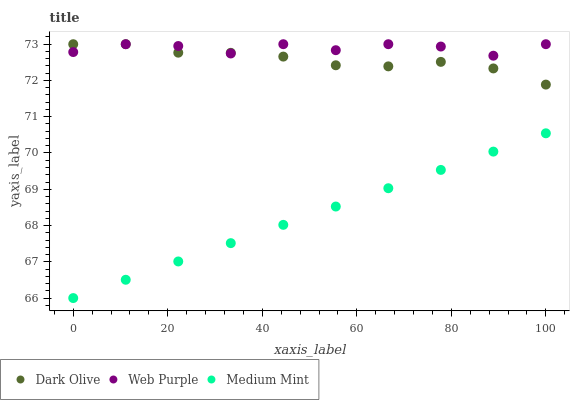Does Medium Mint have the minimum area under the curve?
Answer yes or no. Yes. Does Web Purple have the maximum area under the curve?
Answer yes or no. Yes. Does Dark Olive have the minimum area under the curve?
Answer yes or no. No. Does Dark Olive have the maximum area under the curve?
Answer yes or no. No. Is Medium Mint the smoothest?
Answer yes or no. Yes. Is Web Purple the roughest?
Answer yes or no. Yes. Is Dark Olive the smoothest?
Answer yes or no. No. Is Dark Olive the roughest?
Answer yes or no. No. Does Medium Mint have the lowest value?
Answer yes or no. Yes. Does Dark Olive have the lowest value?
Answer yes or no. No. Does Dark Olive have the highest value?
Answer yes or no. Yes. Is Medium Mint less than Dark Olive?
Answer yes or no. Yes. Is Web Purple greater than Medium Mint?
Answer yes or no. Yes. Does Web Purple intersect Dark Olive?
Answer yes or no. Yes. Is Web Purple less than Dark Olive?
Answer yes or no. No. Is Web Purple greater than Dark Olive?
Answer yes or no. No. Does Medium Mint intersect Dark Olive?
Answer yes or no. No. 